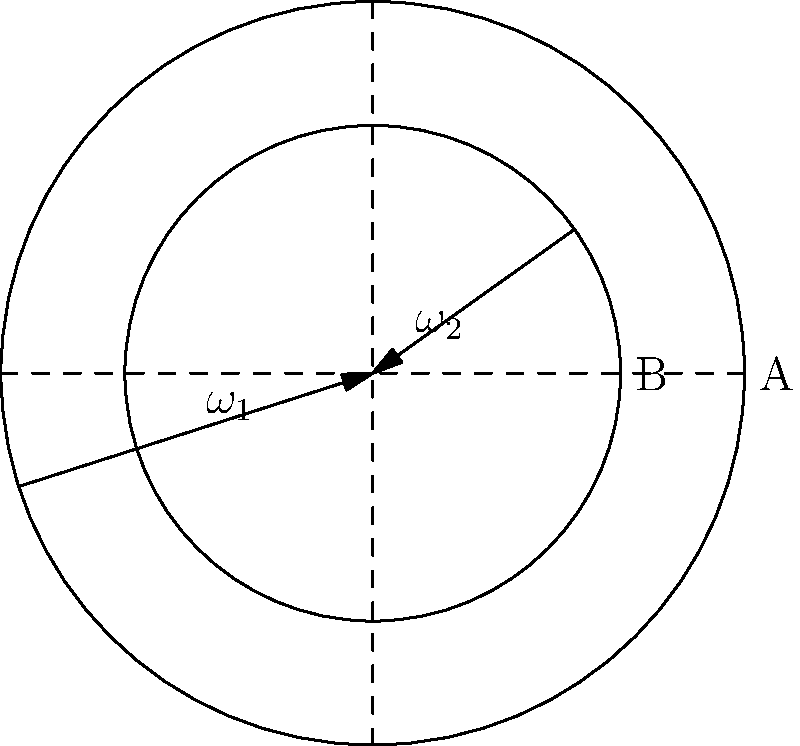In pottery production, the angular velocity of a wheel affects the shape of the vessel being formed. Consider two pottery wheels, A and B, represented by the outer and inner circles respectively in the diagram. Wheel A rotates with angular velocity $\omega_1$, while wheel B rotates with angular velocity $\omega_2$. If the radius of wheel A is 1.5 times that of wheel B, and the linear velocity at the edge of both wheels is the same, what is the ratio of $\omega_1$ to $\omega_2$? Let's approach this step-by-step:

1) First, recall the relationship between linear velocity (v), angular velocity (ω), and radius (r):
   $v = \omega r$

2) We're told that the linear velocity at the edge of both wheels is the same. Let's call this velocity V.
   For wheel A: $V = \omega_1 r_1$
   For wheel B: $V = \omega_2 r_2$

3) We're also told that the radius of wheel A is 1.5 times that of wheel B:
   $r_1 = 1.5r_2$

4) Now, let's set up an equation using the information from steps 2 and 3:
   $\omega_1 (1.5r_2) = \omega_2 r_2$

5) Simplify this equation:
   $1.5\omega_1 r_2 = \omega_2 r_2$

6) The $r_2$ terms cancel out:
   $1.5\omega_1 = \omega_2$

7) To get the ratio $\omega_1 : \omega_2$, divide both sides by $\omega_2$:
   $\frac{1.5\omega_1}{\omega_2} = 1$

8) Simplify:
   $\frac{\omega_1}{\omega_2} = \frac{1}{1.5} = \frac{2}{3}$

Therefore, the ratio of $\omega_1$ to $\omega_2$ is 2:3.
Answer: 2:3 